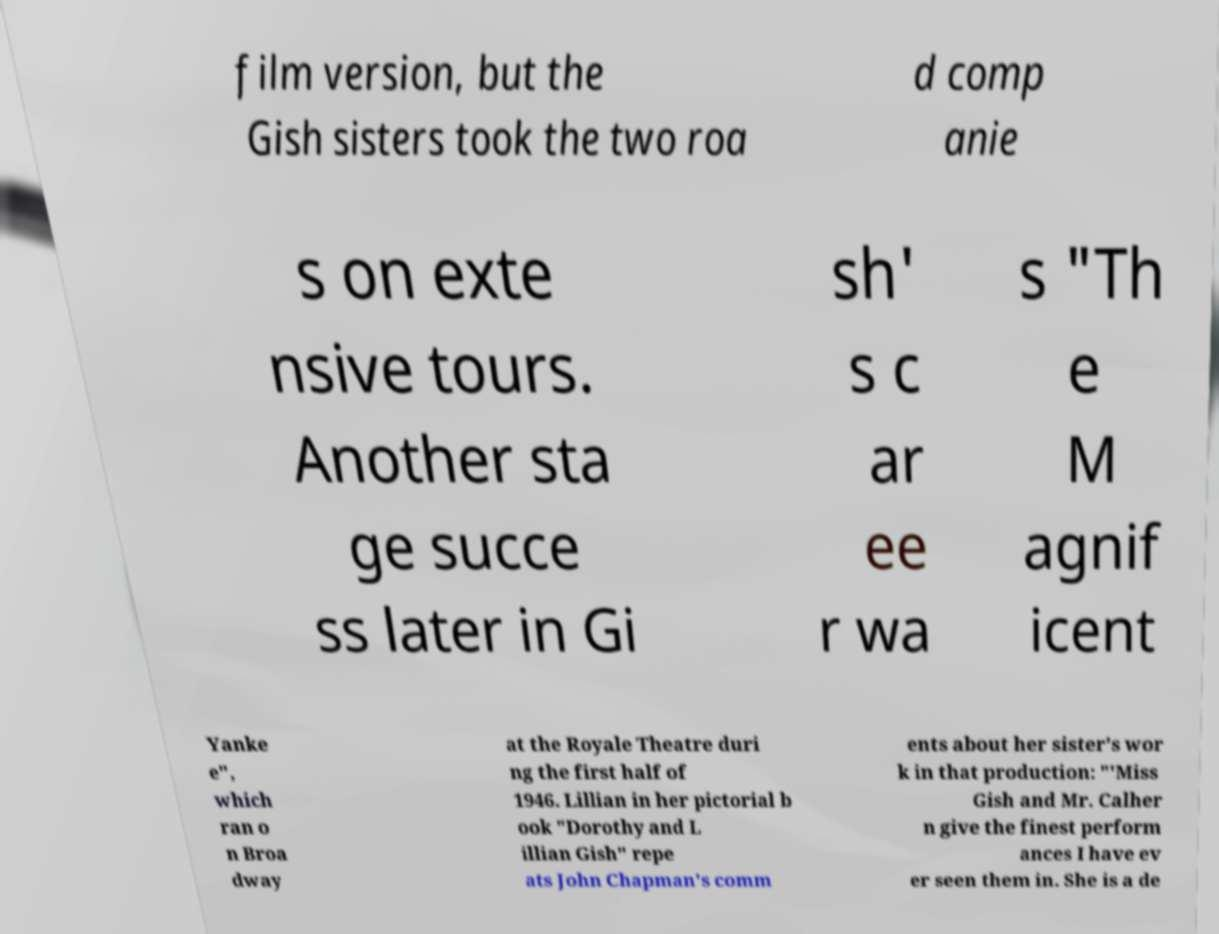What messages or text are displayed in this image? I need them in a readable, typed format. film version, but the Gish sisters took the two roa d comp anie s on exte nsive tours. Another sta ge succe ss later in Gi sh' s c ar ee r wa s "Th e M agnif icent Yanke e", which ran o n Broa dway at the Royale Theatre duri ng the first half of 1946. Lillian in her pictorial b ook "Dorothy and L illian Gish" repe ats John Chapman's comm ents about her sister's wor k in that production: "'Miss Gish and Mr. Calher n give the finest perform ances I have ev er seen them in. She is a de 